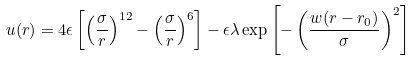Convert formula to latex. <formula><loc_0><loc_0><loc_500><loc_500>u ( r ) = 4 \epsilon \left [ \left ( \frac { \sigma } { r } \right ) ^ { 1 2 } - \left ( \frac { \sigma } { r } \right ) ^ { 6 } \right ] - \epsilon \lambda \exp \left [ - \left ( \frac { w ( r - r _ { 0 } ) } { \sigma } \right ) ^ { 2 } \right ]</formula> 